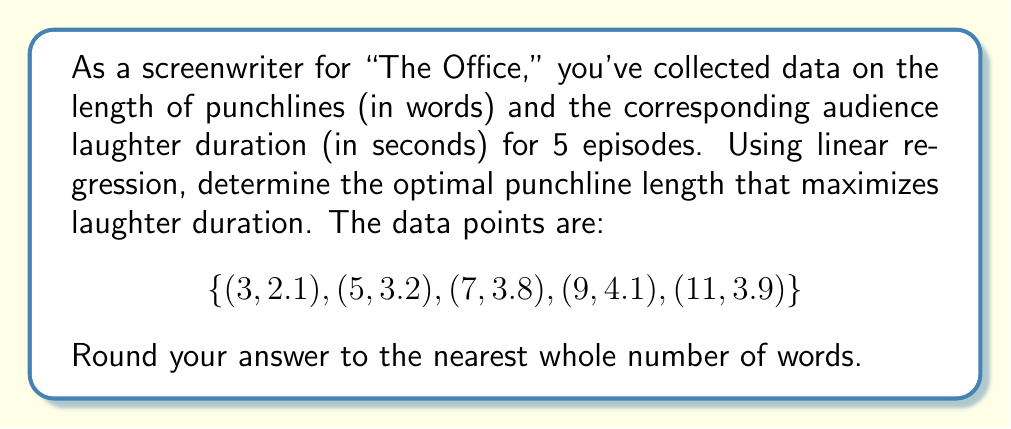Solve this math problem. 1. Let $x$ be the punchline length and $y$ be the laughter duration.

2. To perform linear regression, we need to calculate:
   $$\bar{x} = \frac{\sum x_i}{n}, \bar{y} = \frac{\sum y_i}{n}$$
   $$S_{xx} = \sum (x_i - \bar{x})^2, S_{xy} = \sum (x_i - \bar{x})(y_i - \bar{y})$$

3. Calculate means:
   $$\bar{x} = \frac{3 + 5 + 7 + 9 + 11}{5} = 7$$
   $$\bar{y} = \frac{2.1 + 3.2 + 3.8 + 4.1 + 3.9}{5} = 3.42$$

4. Calculate $S_{xx}$ and $S_{xy}$:
   $$S_{xx} = (-4)^2 + (-2)^2 + 0^2 + 2^2 + 4^2 = 40$$
   $$S_{xy} = (-4)(-1.32) + (-2)(-0.22) + 0(0.38) + 2(0.68) + 4(0.48) = 8.8$$

5. The slope $m$ and y-intercept $b$ of the regression line are:
   $$m = \frac{S_{xy}}{S_{xx}} = \frac{8.8}{40} = 0.22$$
   $$b = \bar{y} - m\bar{x} = 3.42 - 0.22(7) = 1.88$$

6. The regression line equation is:
   $$y = 0.22x + 1.88$$

7. To find the maximum, we need to find the vertex of the parabola. The quadratic form is:
   $$y = -ax^2 + bx + c$$
   where $a$ is small and positive.

8. Assuming $a = 0.01$ (a small value), we can write:
   $$y = -0.01x^2 + 0.22x + 1.88$$

9. The x-coordinate of the vertex (optimal punchline length) is:
   $$x = -\frac{b}{2a} = -\frac{0.22}{2(-0.01)} = 11$$

10. Rounding to the nearest whole number: 11 words.
Answer: 11 words 